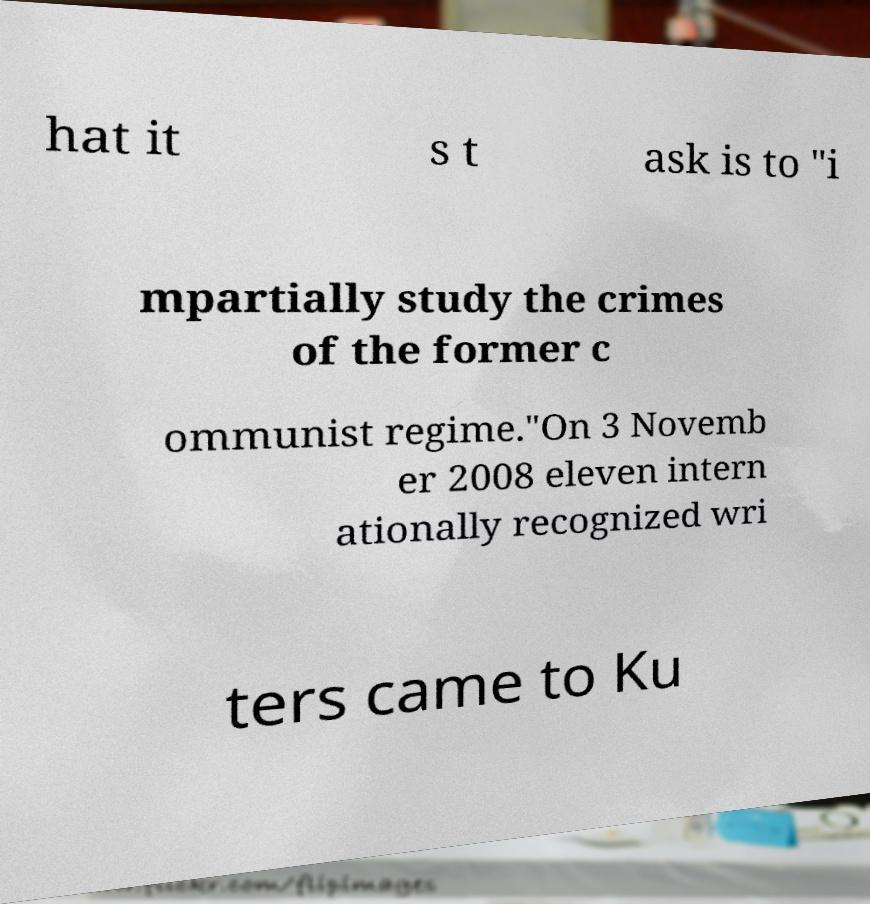What messages or text are displayed in this image? I need them in a readable, typed format. hat it s t ask is to "i mpartially study the crimes of the former c ommunist regime."On 3 Novemb er 2008 eleven intern ationally recognized wri ters came to Ku 